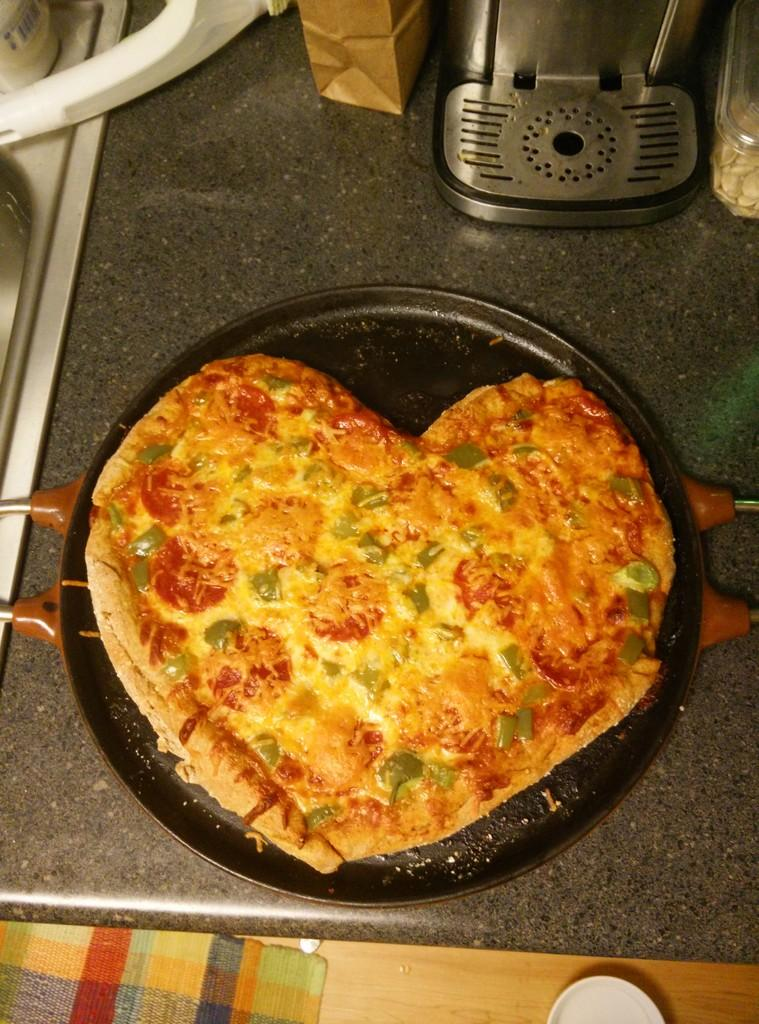What is present in the image related to cooking? There is a cooking pan in the image. What type of food is on the cooking pan? There is pizza on the cooking pan. What type of plough is being used to prepare the pizza in the image? There is no plough present in the image, and the pizza is already prepared on the cooking pan. What type of sheet is covering the pizza in the image? There is no sheet covering the pizza in the image; it is visible on the cooking pan. 